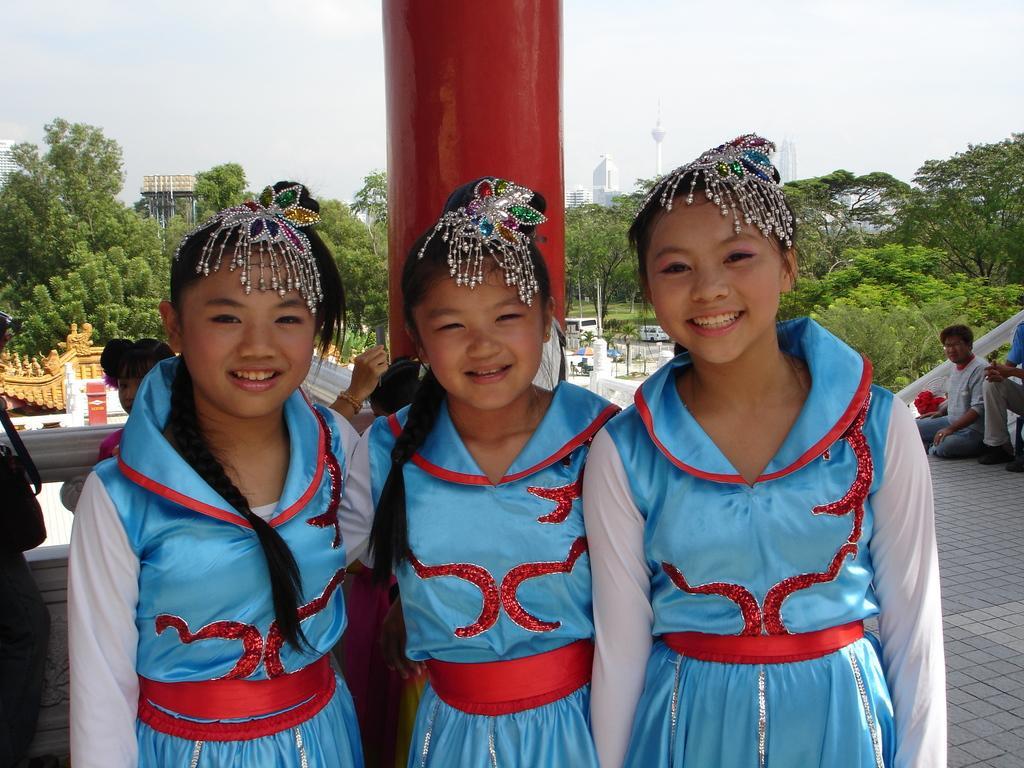Describe this image in one or two sentences. In front of the picture, the three girls wearing blue dresses are posing for the photo. All of them are smiling. Behind them, we see a red pillar and people sitting on the floor. In the background, there are trees and vehicles moving on the road. We even see buildings and a tower. At the top of the picture, we see the sky. 